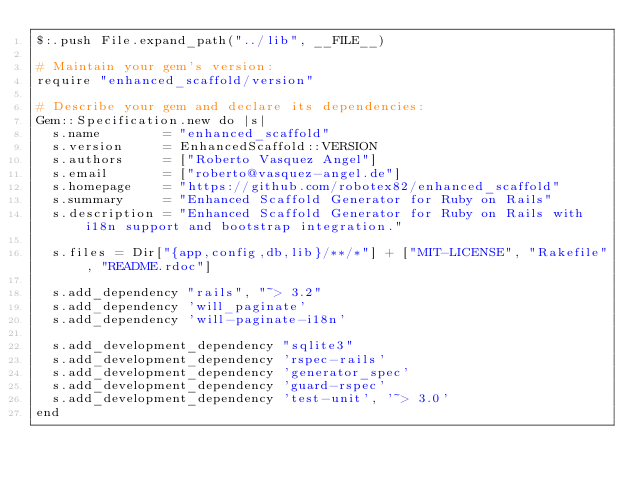Convert code to text. <code><loc_0><loc_0><loc_500><loc_500><_Ruby_>$:.push File.expand_path("../lib", __FILE__)

# Maintain your gem's version:
require "enhanced_scaffold/version"

# Describe your gem and declare its dependencies:
Gem::Specification.new do |s|
  s.name        = "enhanced_scaffold"
  s.version     = EnhancedScaffold::VERSION
  s.authors     = ["Roberto Vasquez Angel"]
  s.email       = ["roberto@vasquez-angel.de"]
  s.homepage    = "https://github.com/robotex82/enhanced_scaffold"
  s.summary     = "Enhanced Scaffold Generator for Ruby on Rails"
  s.description = "Enhanced Scaffold Generator for Ruby on Rails with i18n support and bootstrap integration."

  s.files = Dir["{app,config,db,lib}/**/*"] + ["MIT-LICENSE", "Rakefile", "README.rdoc"]

  s.add_dependency "rails", "~> 3.2"
  s.add_dependency 'will_paginate'
  s.add_dependency 'will-paginate-i18n'

  s.add_development_dependency "sqlite3"
  s.add_development_dependency 'rspec-rails'
  s.add_development_dependency 'generator_spec'
  s.add_development_dependency 'guard-rspec'
  s.add_development_dependency 'test-unit', '~> 3.0'
end
</code> 